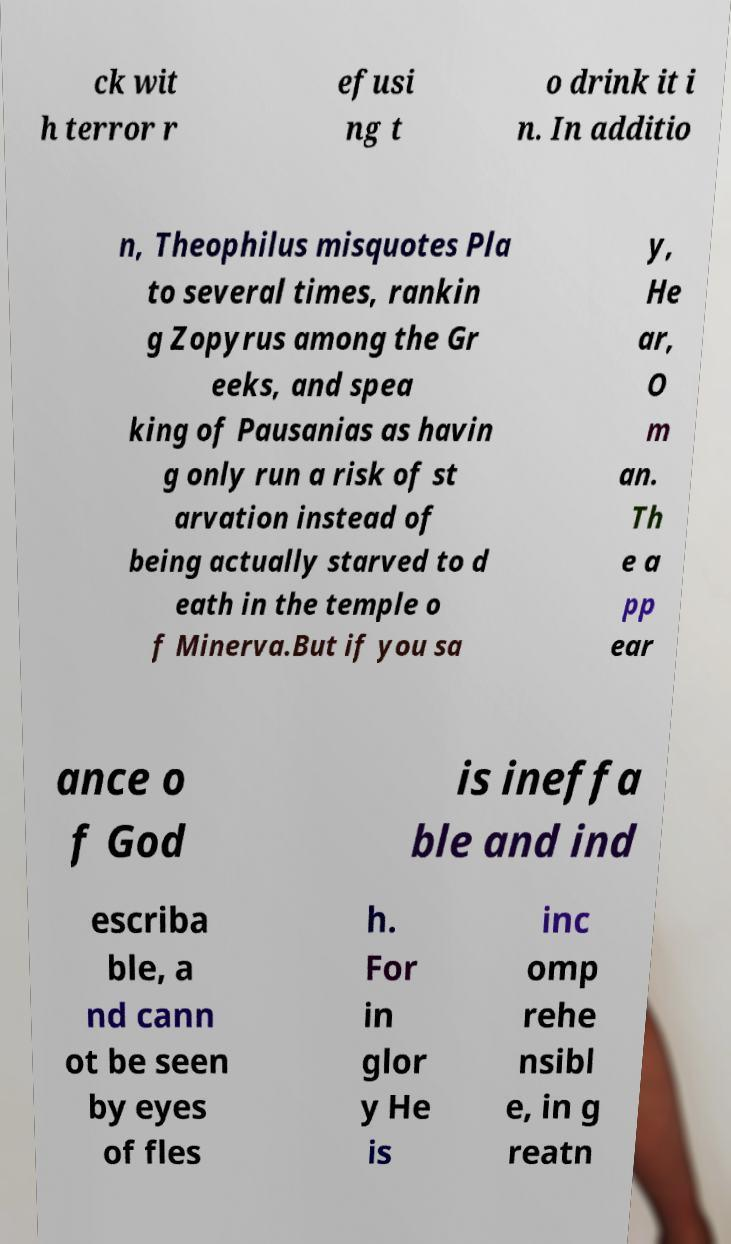There's text embedded in this image that I need extracted. Can you transcribe it verbatim? ck wit h terror r efusi ng t o drink it i n. In additio n, Theophilus misquotes Pla to several times, rankin g Zopyrus among the Gr eeks, and spea king of Pausanias as havin g only run a risk of st arvation instead of being actually starved to d eath in the temple o f Minerva.But if you sa y, He ar, O m an. Th e a pp ear ance o f God is ineffa ble and ind escriba ble, a nd cann ot be seen by eyes of fles h. For in glor y He is inc omp rehe nsibl e, in g reatn 